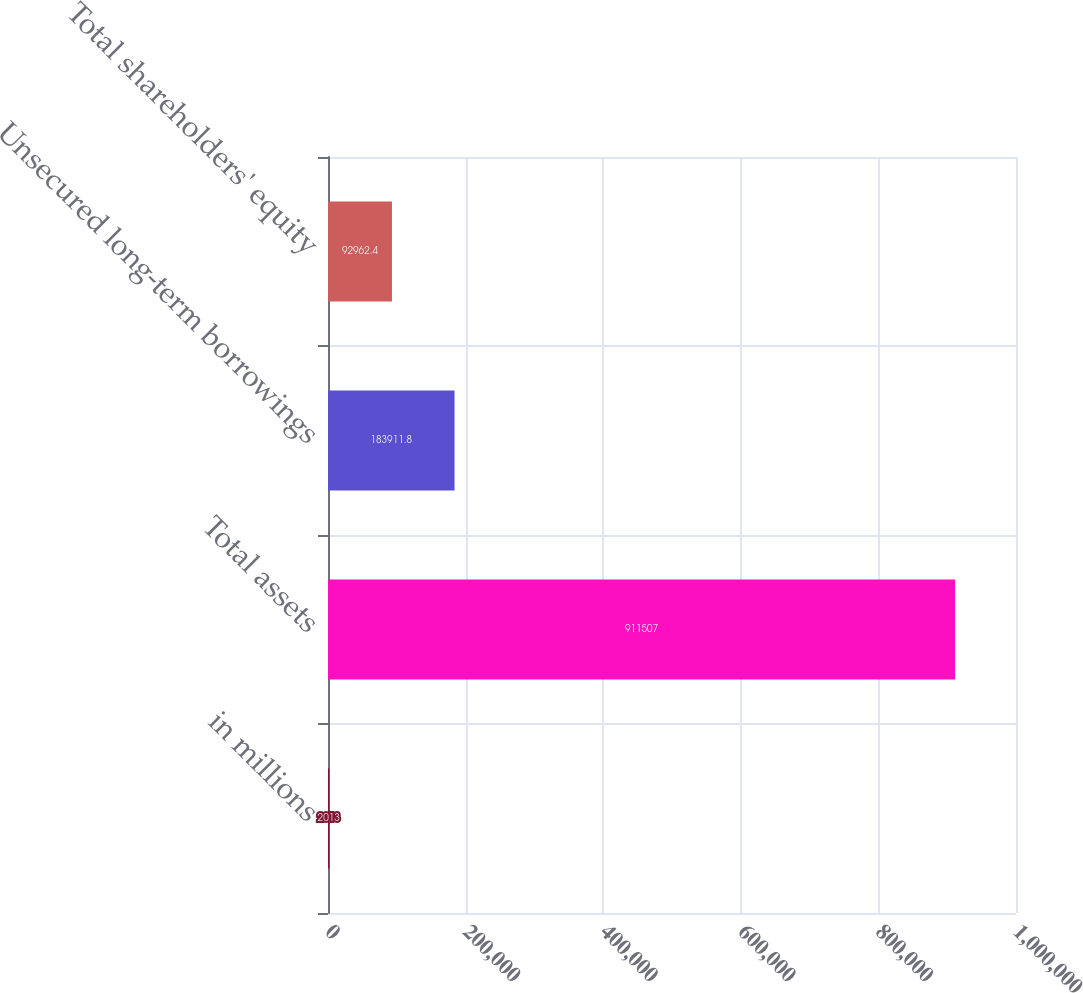<chart> <loc_0><loc_0><loc_500><loc_500><bar_chart><fcel>in millions<fcel>Total assets<fcel>Unsecured long-term borrowings<fcel>Total shareholders' equity<nl><fcel>2013<fcel>911507<fcel>183912<fcel>92962.4<nl></chart> 